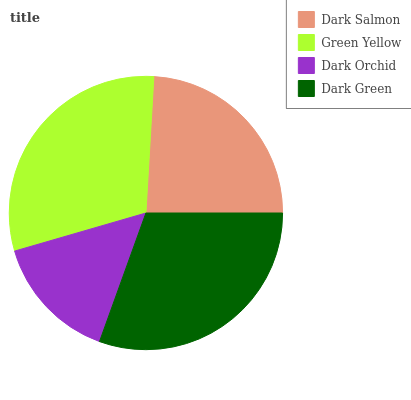Is Dark Orchid the minimum?
Answer yes or no. Yes. Is Dark Green the maximum?
Answer yes or no. Yes. Is Green Yellow the minimum?
Answer yes or no. No. Is Green Yellow the maximum?
Answer yes or no. No. Is Green Yellow greater than Dark Salmon?
Answer yes or no. Yes. Is Dark Salmon less than Green Yellow?
Answer yes or no. Yes. Is Dark Salmon greater than Green Yellow?
Answer yes or no. No. Is Green Yellow less than Dark Salmon?
Answer yes or no. No. Is Green Yellow the high median?
Answer yes or no. Yes. Is Dark Salmon the low median?
Answer yes or no. Yes. Is Dark Orchid the high median?
Answer yes or no. No. Is Green Yellow the low median?
Answer yes or no. No. 